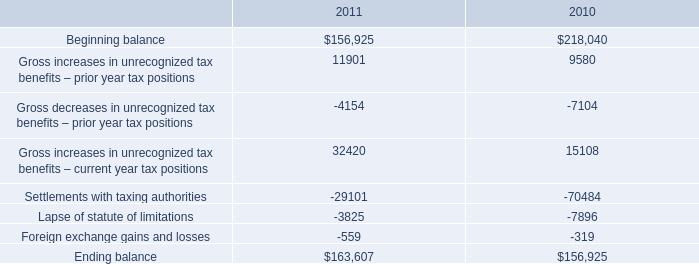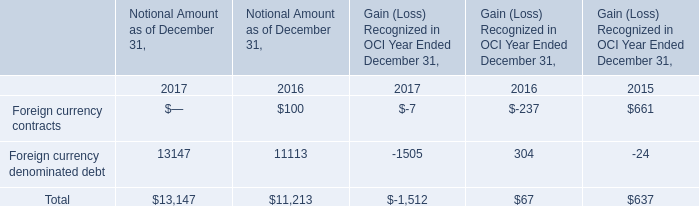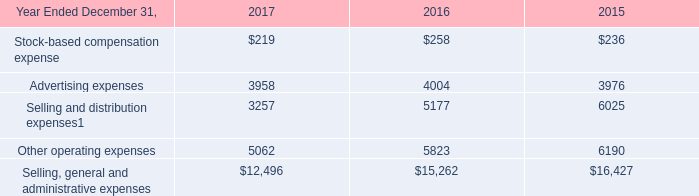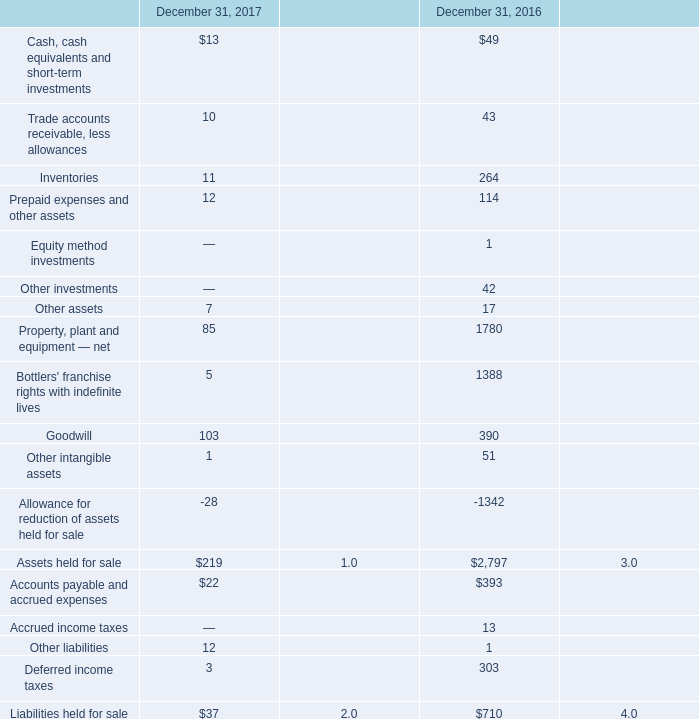What's the total amount of the Stock-based compensation expense in the years where Goodwill is greater than 0? 
Computations: (219 + 258)
Answer: 477.0. 